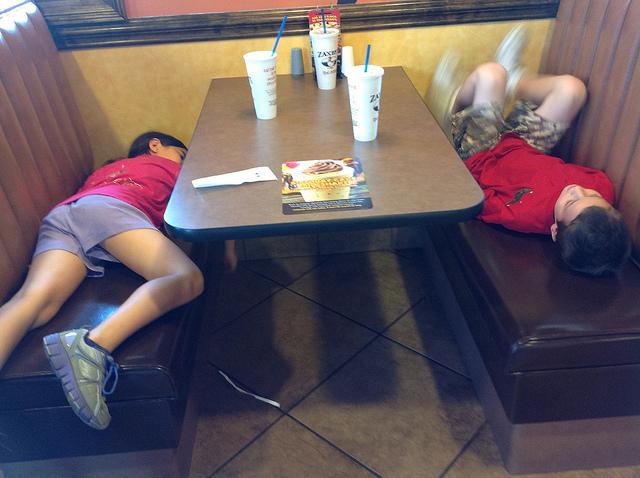What are the two people playing?
Short answer required. Nothing. What type of restaurant could this be located?
Quick response, please. Diner. Is this family finished with their meal?
Short answer required. Yes. Is this the proper way to utilize a restaurant booth?
Answer briefly. No. 